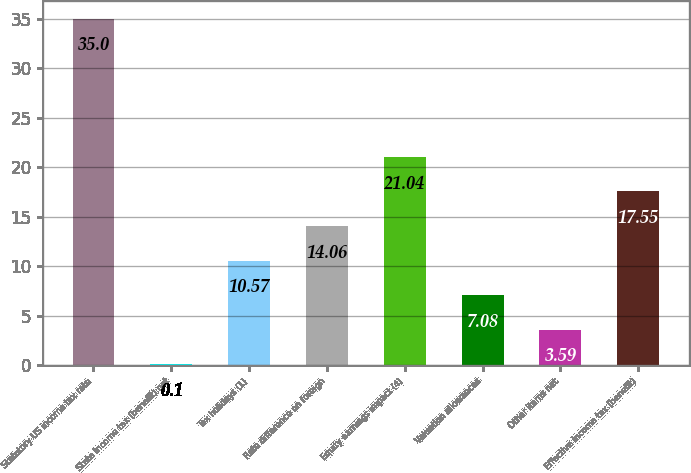Convert chart. <chart><loc_0><loc_0><loc_500><loc_500><bar_chart><fcel>Statutory US income tax rate<fcel>State income tax (benefit) net<fcel>Tax holidays (1)<fcel>Rate difference on foreign<fcel>Equity earnings impact (4)<fcel>Valuation allowances<fcel>Other items net<fcel>Effective income tax (benefit)<nl><fcel>35<fcel>0.1<fcel>10.57<fcel>14.06<fcel>21.04<fcel>7.08<fcel>3.59<fcel>17.55<nl></chart> 